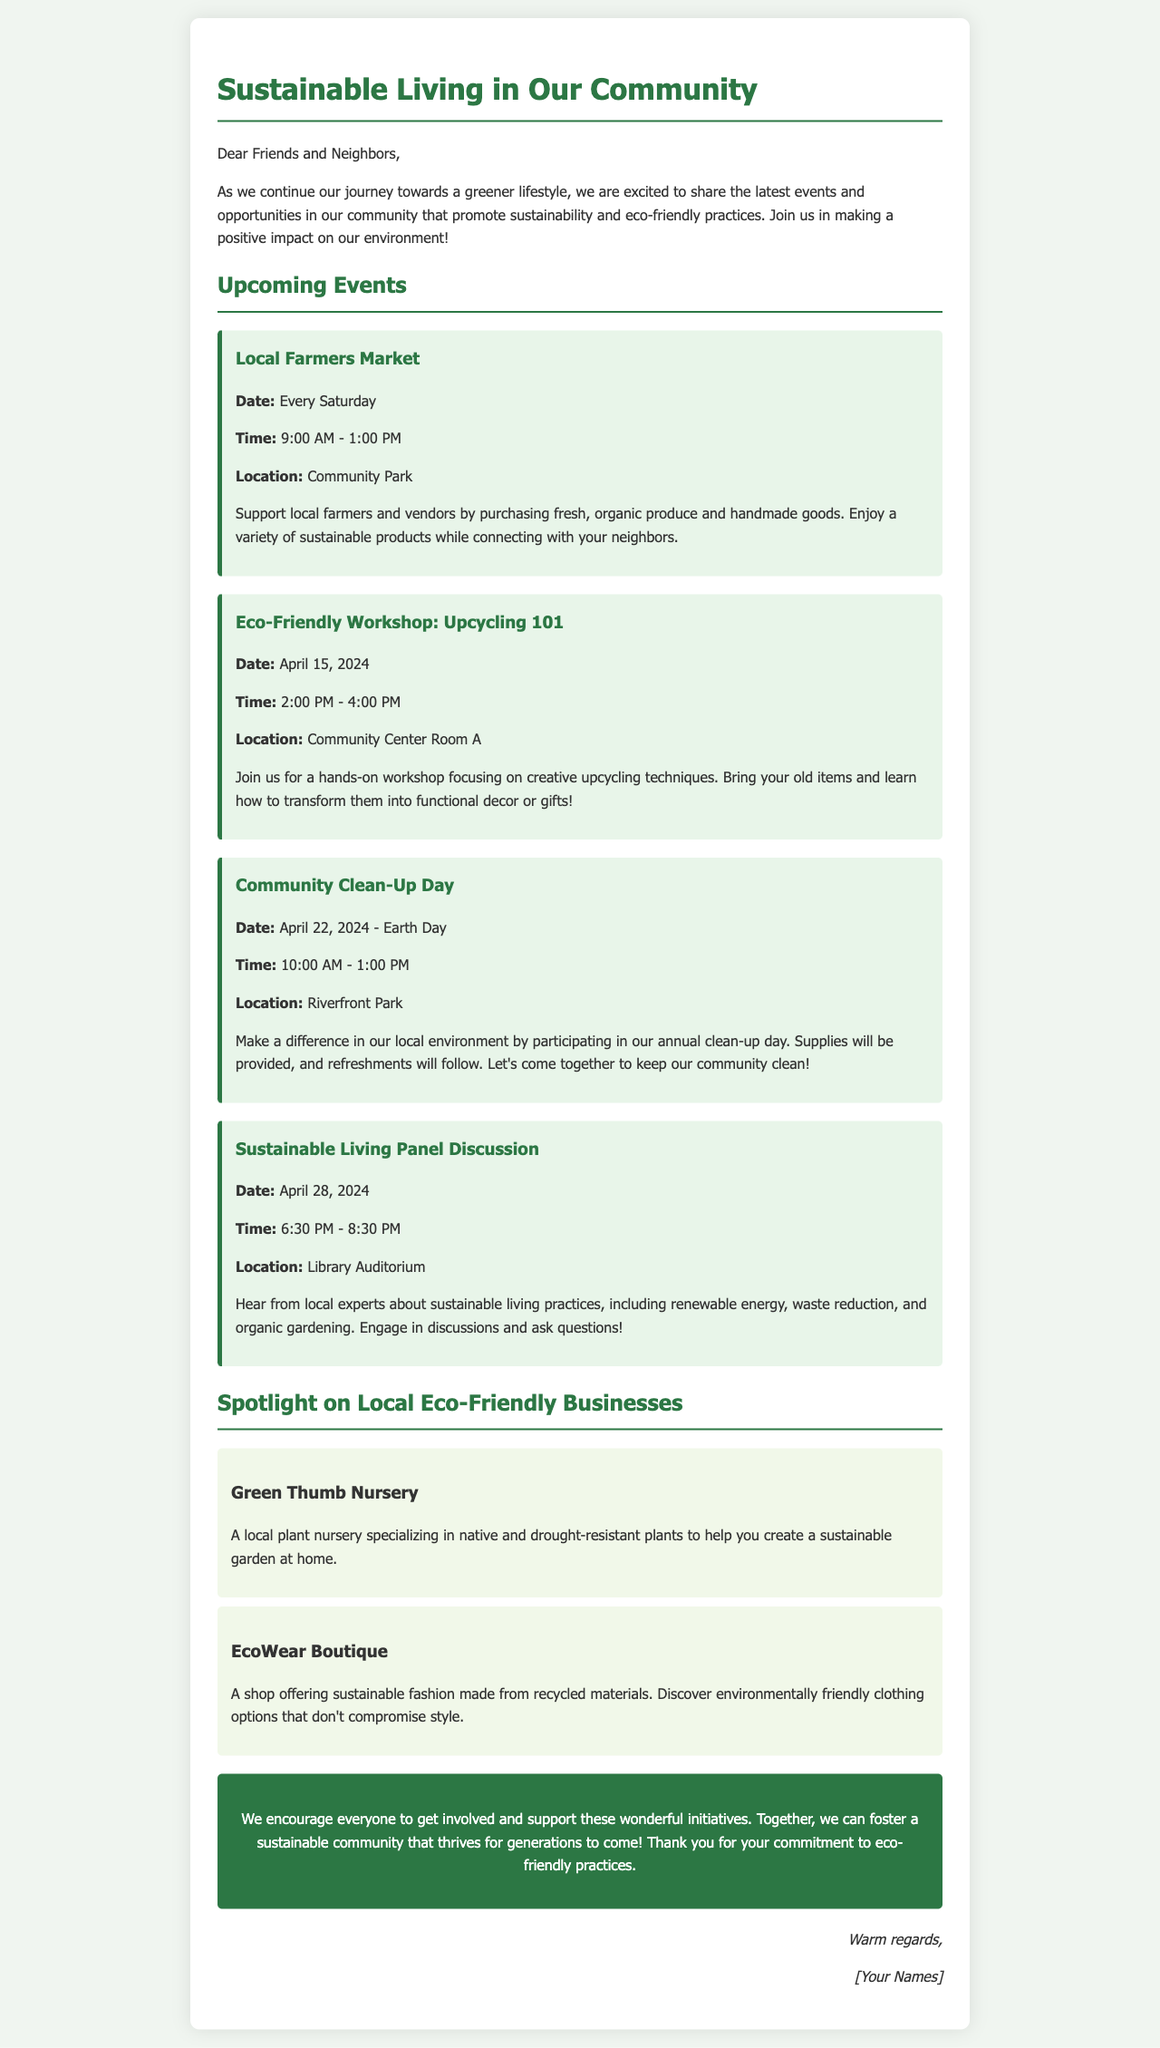what is the main topic of the newsletter? The newsletter focuses on promoting sustainability and eco-friendly practices in the community.
Answer: Sustainable Living when is the Community Clean-Up Day scheduled? The Community Clean-Up Day is on April 22, 2024.
Answer: April 22, 2024 where is the Eco-Friendly Workshop: Upcycling 101 held? The workshop will take place in Community Center Room A.
Answer: Community Center Room A how often does the Local Farmers Market occur? The Local Farmers Market occurs every Saturday.
Answer: Every Saturday what time does the Sustainable Living Panel Discussion start? The panel discussion begins at 6:30 PM.
Answer: 6:30 PM what is unique about Green Thumb Nursery? Green Thumb Nursery specializes in native and drought-resistant plants.
Answer: Native and drought-resistant plants which eco-friendly business offers sustainable fashion? EcoWear Boutique offers sustainable fashion made from recycled materials.
Answer: EcoWear Boutique what is the significance of April 22, 2024 in the newsletter? April 22, 2024 is Earth Day and is marked by the Community Clean-Up Day event.
Answer: Earth Day 